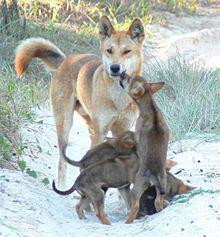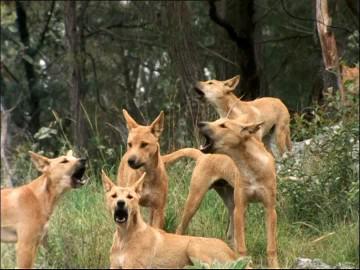The first image is the image on the left, the second image is the image on the right. Evaluate the accuracy of this statement regarding the images: "There is only one animal in the picture on the left.". Is it true? Answer yes or no. No. The first image is the image on the left, the second image is the image on the right. Evaluate the accuracy of this statement regarding the images: "An image shows an adult dog with at least one pup standing to reach it.". Is it true? Answer yes or no. Yes. 